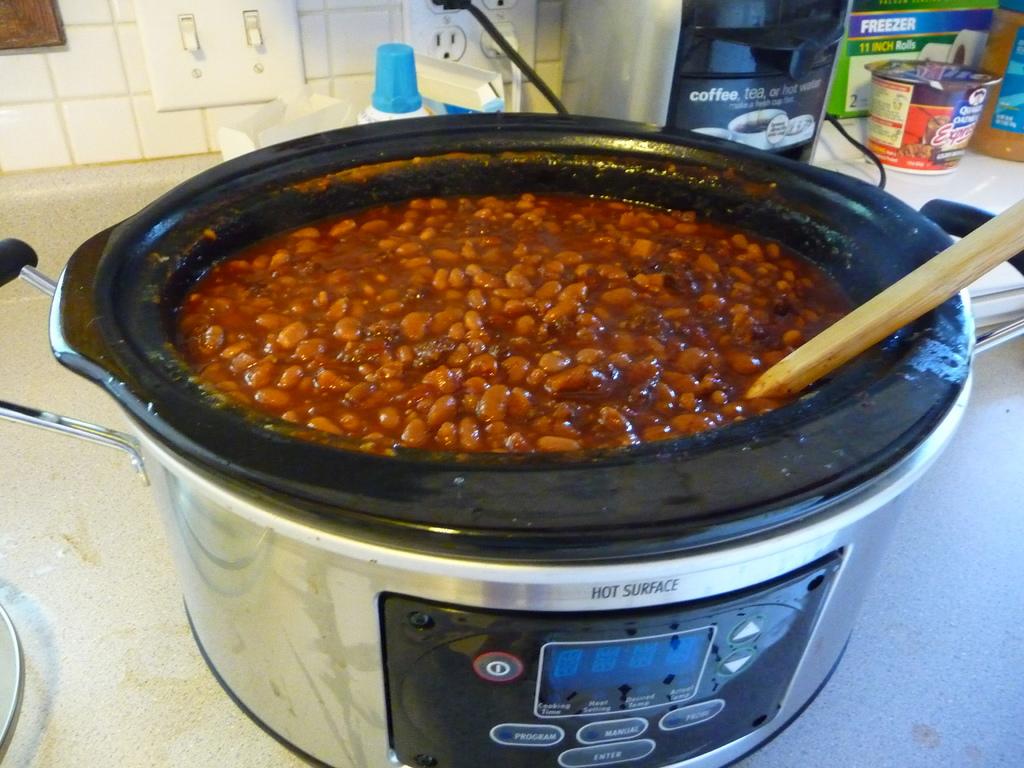What is the surface?
Ensure brevity in your answer.  Hot. 